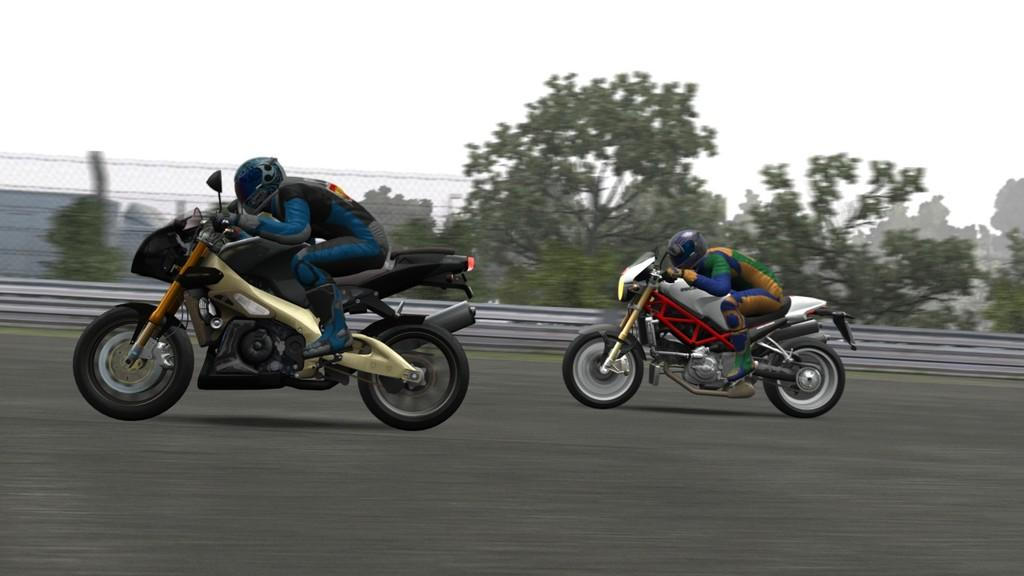How many people are in the image? There are two people in the image. What are the people doing in the image? The people are riding bikes. Where are the bikes located in the image? The bikes are on a road. What can be seen in the background of the image? There are trees, buildings, a net fence, and the sky visible in the background of the image. What type of skin is visible on the trees in the image? There is no mention of the type of skin on the trees in the image, as trees do not have skin. 